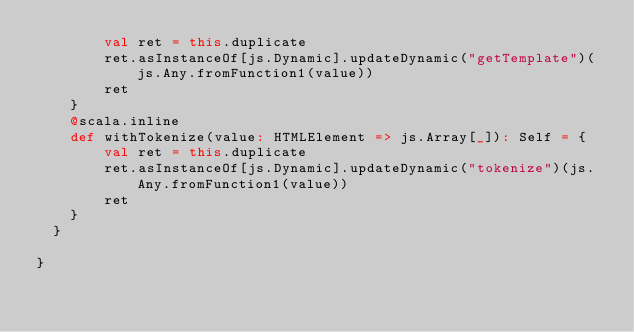<code> <loc_0><loc_0><loc_500><loc_500><_Scala_>        val ret = this.duplicate
        ret.asInstanceOf[js.Dynamic].updateDynamic("getTemplate")(js.Any.fromFunction1(value))
        ret
    }
    @scala.inline
    def withTokenize(value: HTMLElement => js.Array[_]): Self = {
        val ret = this.duplicate
        ret.asInstanceOf[js.Dynamic].updateDynamic("tokenize")(js.Any.fromFunction1(value))
        ret
    }
  }
  
}

</code> 